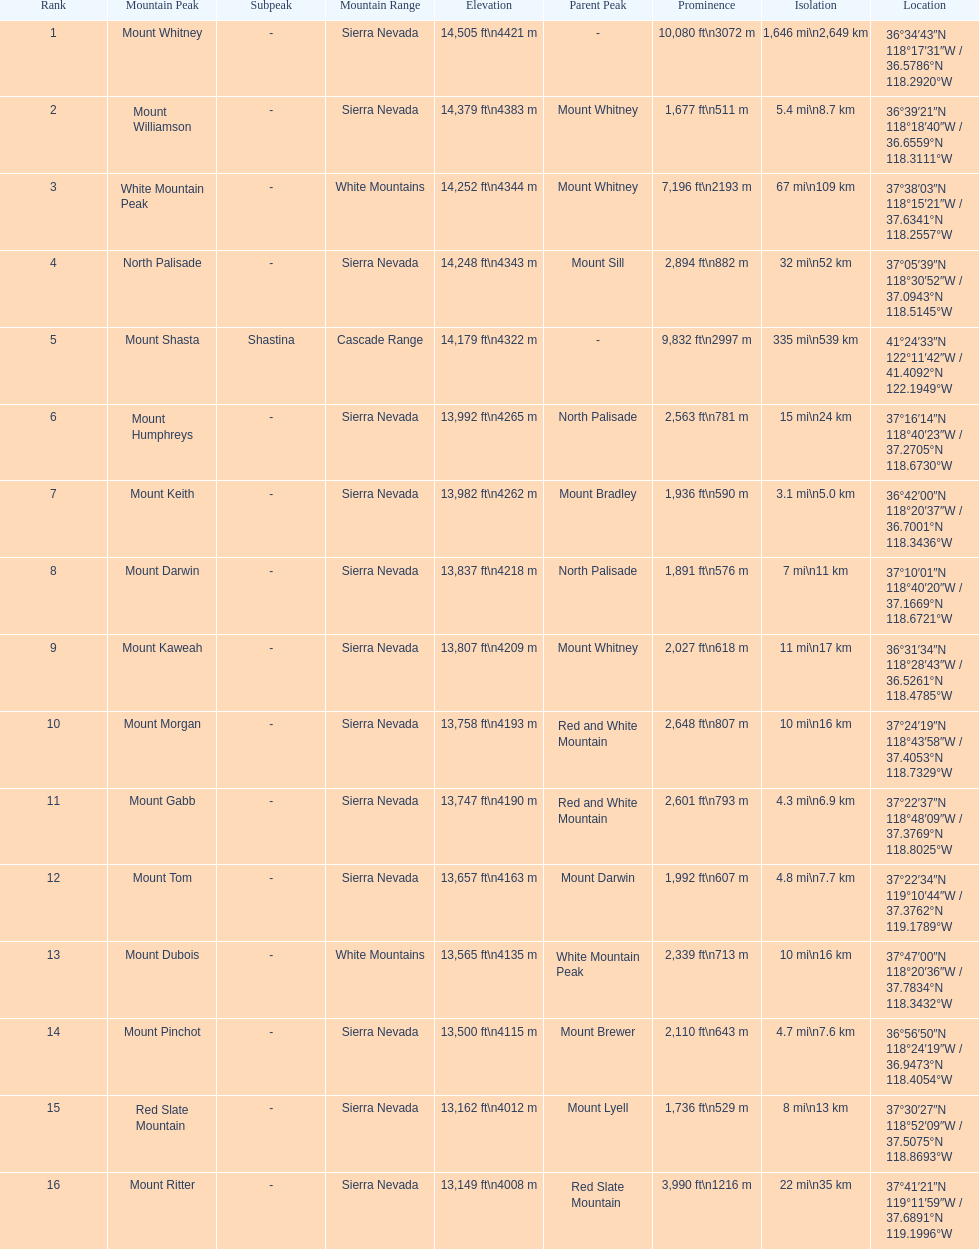Is the peak of mount keith above or below the peak of north palisade? Below. 